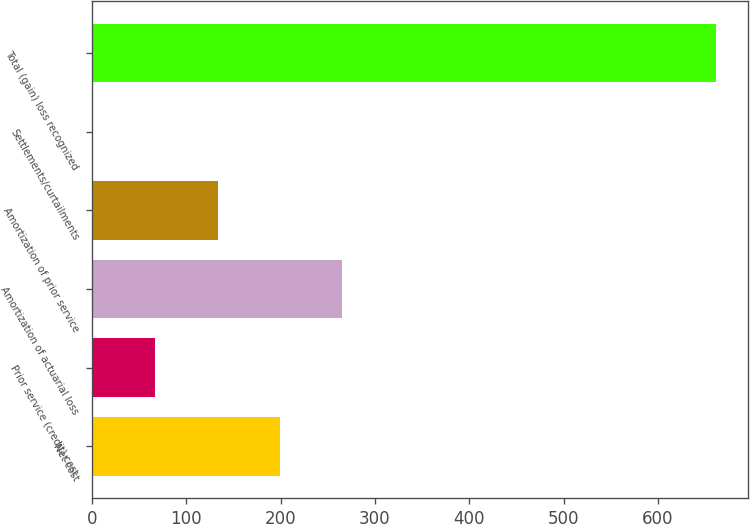Convert chart. <chart><loc_0><loc_0><loc_500><loc_500><bar_chart><fcel>Net cost<fcel>Prior service (credit) cost<fcel>Amortization of actuarial loss<fcel>Amortization of prior service<fcel>Settlements/curtailments<fcel>Total (gain) loss recognized<nl><fcel>199.3<fcel>67.1<fcel>265.4<fcel>133.2<fcel>1<fcel>662<nl></chart> 